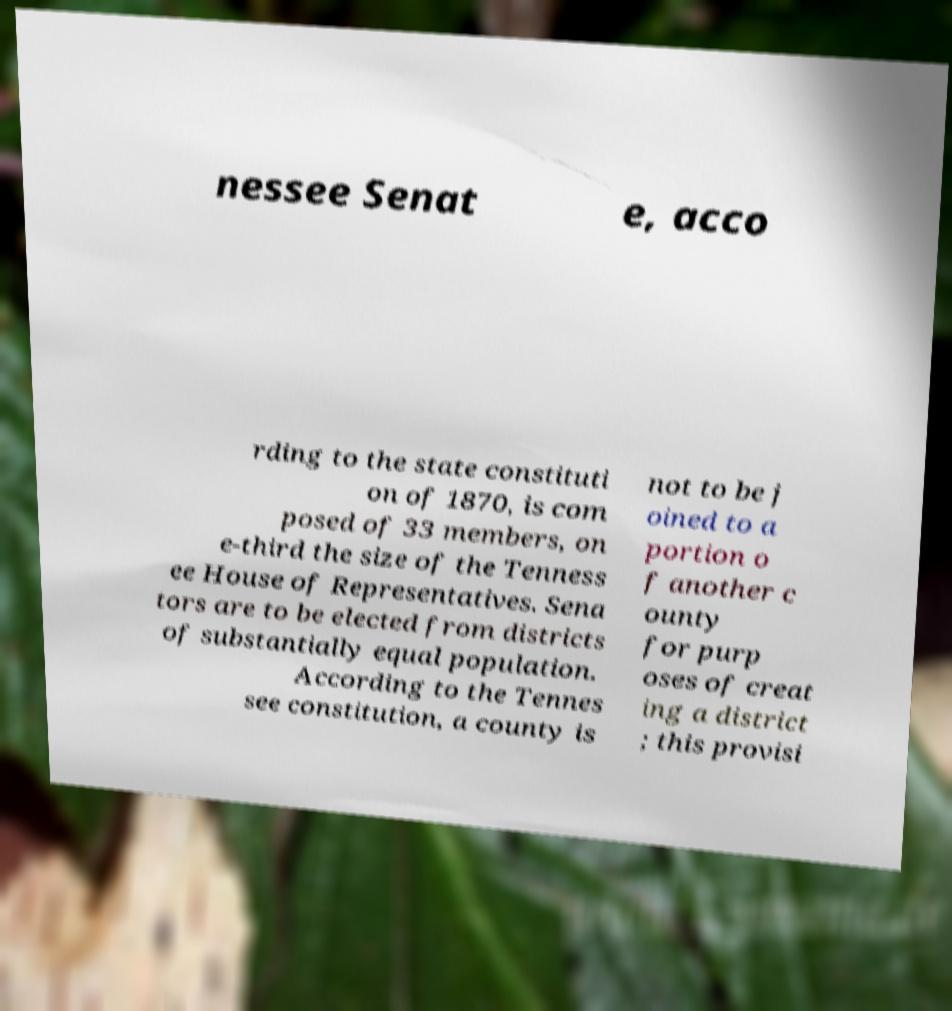What messages or text are displayed in this image? I need them in a readable, typed format. nessee Senat e, acco rding to the state constituti on of 1870, is com posed of 33 members, on e-third the size of the Tenness ee House of Representatives. Sena tors are to be elected from districts of substantially equal population. According to the Tennes see constitution, a county is not to be j oined to a portion o f another c ounty for purp oses of creat ing a district ; this provisi 